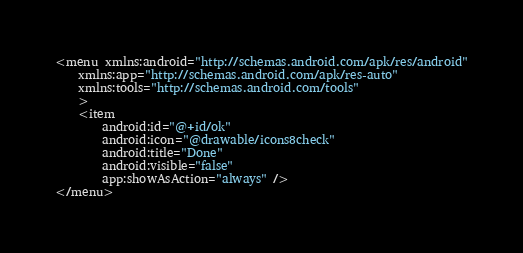Convert code to text. <code><loc_0><loc_0><loc_500><loc_500><_XML_><menu xmlns:android="http://schemas.android.com/apk/res/android"
    xmlns:app="http://schemas.android.com/apk/res-auto"
    xmlns:tools="http://schemas.android.com/tools"
    >
    <item
        android:id="@+id/ok"
        android:icon="@drawable/icons8check"
        android:title="Done"
        android:visible="false"
        app:showAsAction="always" />
</menu>
</code> 